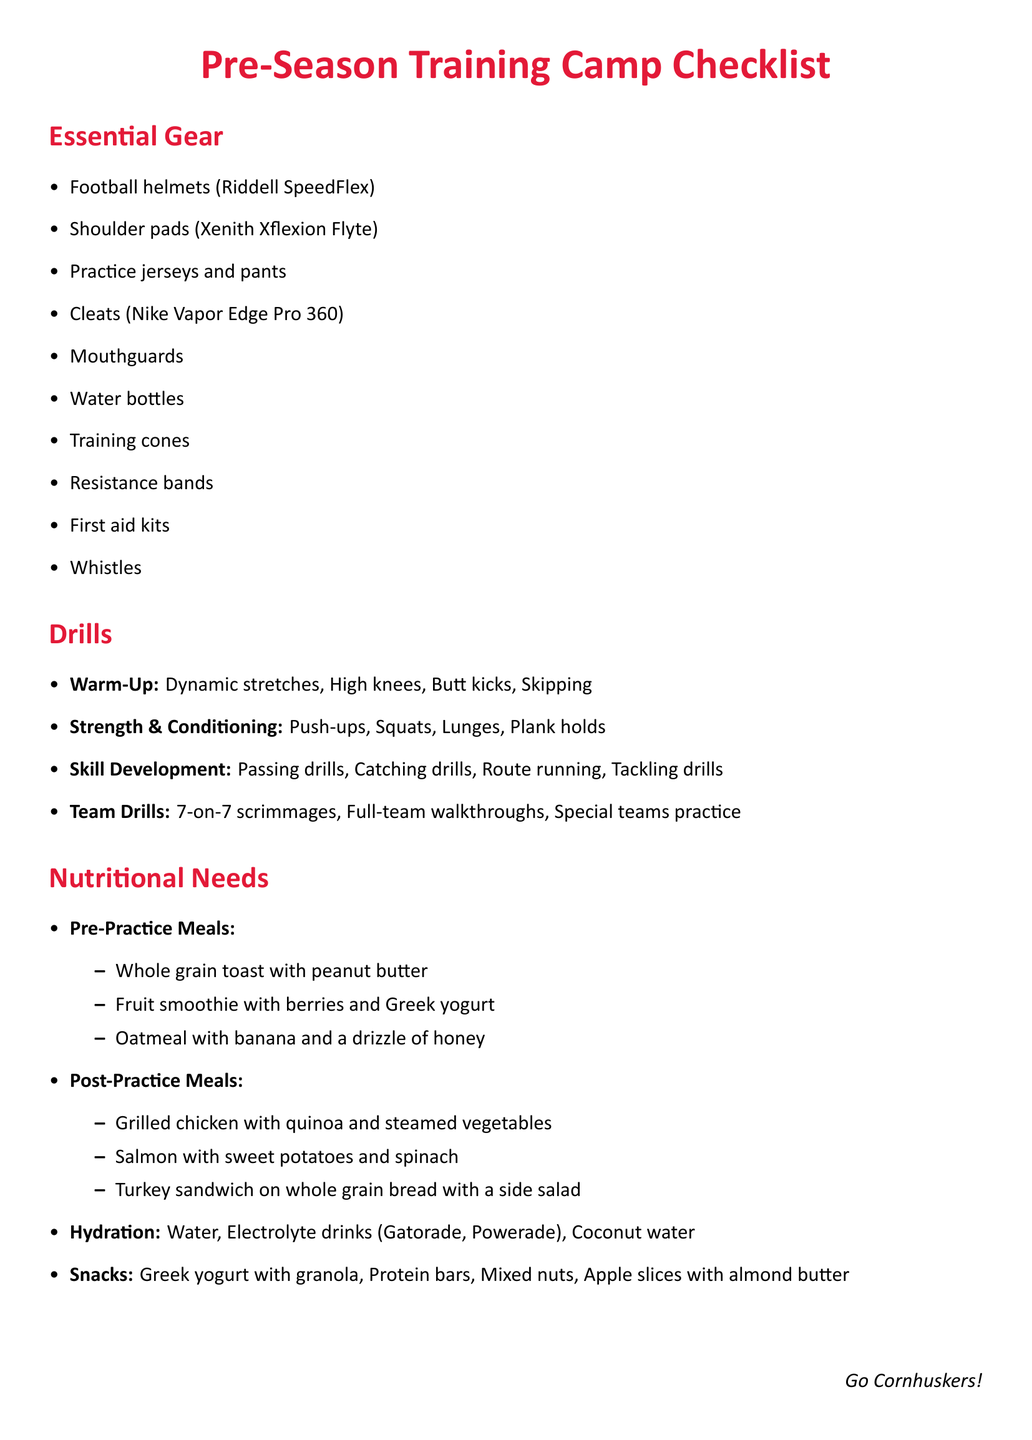What type of helmets are listed? The document specifies the type of helmets that should be used, which is Riddell SpeedFlex.
Answer: Riddell SpeedFlex What are the first two drills listed under Skill Development? The first two drills in the Skill Development section are mentioned clearly in the document.
Answer: Passing drills, Catching drills What is listed as a pre-practice meal? The document provides examples of pre-practice meals, one of which is whole grain toast with peanut butter.
Answer: Whole grain toast with peanut butter How many items are included in the Essential Gear section? The Essential Gear section contains a specific number of items that can be counted directly.
Answer: 10 Which drink is recommended for hydration? The hydration section suggests specific drinks for hydration needs, one being water.
Answer: Water What are the last items mentioned under snacks? The document details health snack options, one of which is apple slices with almond butter.
Answer: Apple slices with almond butter What type of daily practice activity involves a scrimmage? The document specifies a team drill that includes a scrimmage, which involves seven players.
Answer: 7-on-7 scrimmages What type of shoes are suggested in the gear list? The appropriate footwear for practice is mentioned, specifically Nike Vapor Edge Pro 360.
Answer: Nike Vapor Edge Pro 360 